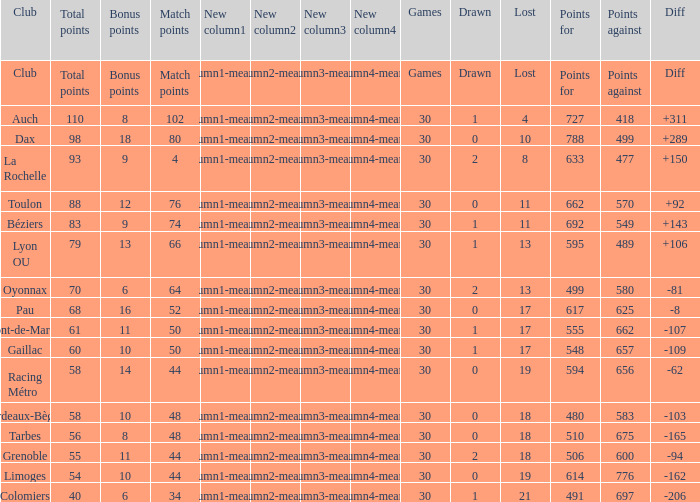How many bonus points did the Colomiers earn? 6.0. 